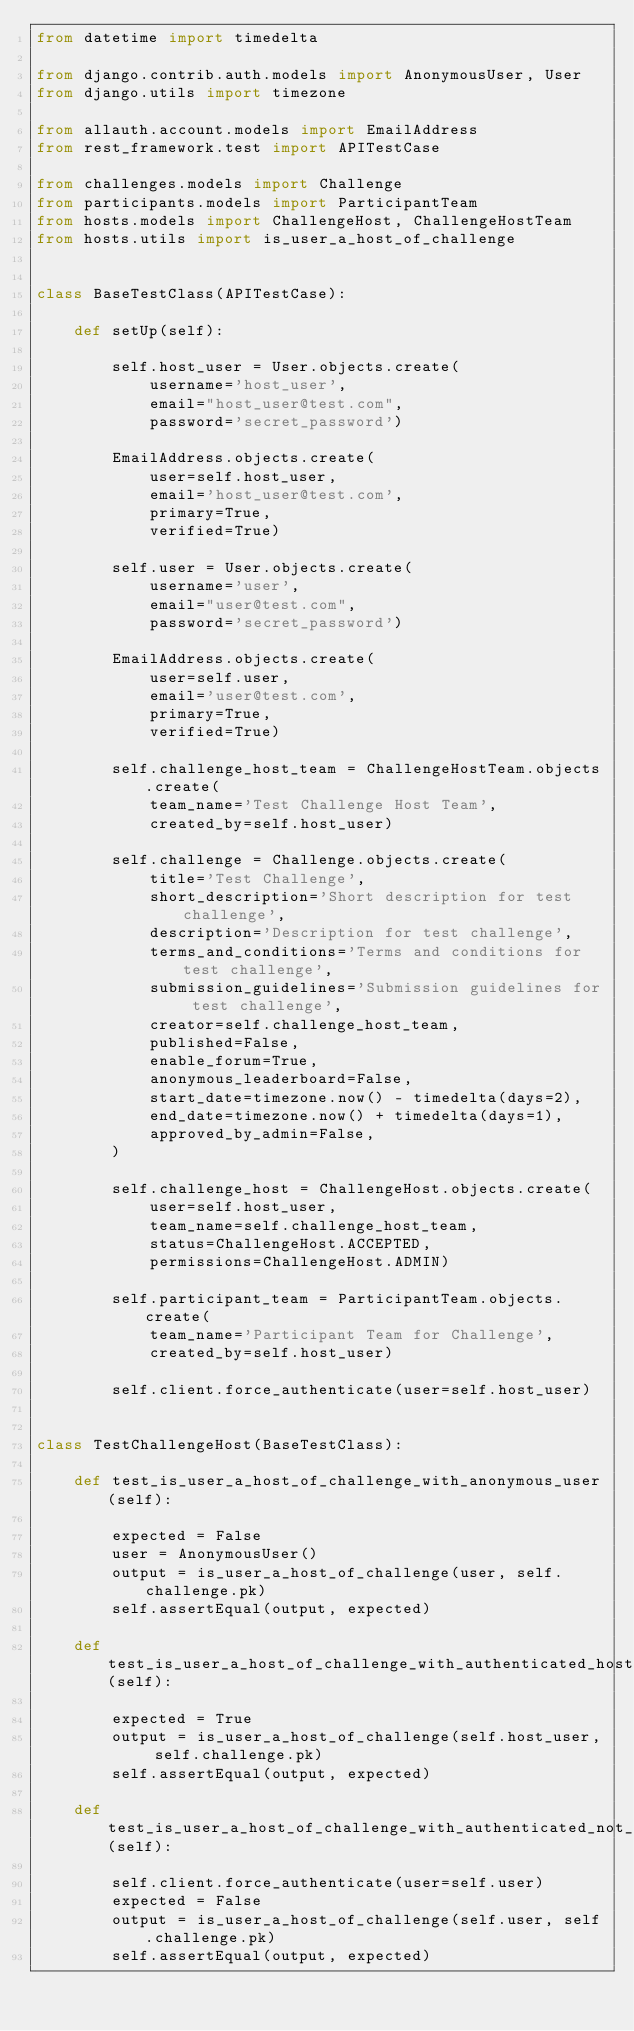<code> <loc_0><loc_0><loc_500><loc_500><_Python_>from datetime import timedelta

from django.contrib.auth.models import AnonymousUser, User
from django.utils import timezone

from allauth.account.models import EmailAddress
from rest_framework.test import APITestCase

from challenges.models import Challenge
from participants.models import ParticipantTeam
from hosts.models import ChallengeHost, ChallengeHostTeam
from hosts.utils import is_user_a_host_of_challenge


class BaseTestClass(APITestCase):

    def setUp(self):

        self.host_user = User.objects.create(
            username='host_user',
            email="host_user@test.com",
            password='secret_password')

        EmailAddress.objects.create(
            user=self.host_user,
            email='host_user@test.com',
            primary=True,
            verified=True)

        self.user = User.objects.create(
            username='user',
            email="user@test.com",
            password='secret_password')

        EmailAddress.objects.create(
            user=self.user,
            email='user@test.com',
            primary=True,
            verified=True)

        self.challenge_host_team = ChallengeHostTeam.objects.create(
            team_name='Test Challenge Host Team',
            created_by=self.host_user)

        self.challenge = Challenge.objects.create(
            title='Test Challenge',
            short_description='Short description for test challenge',
            description='Description for test challenge',
            terms_and_conditions='Terms and conditions for test challenge',
            submission_guidelines='Submission guidelines for test challenge',
            creator=self.challenge_host_team,
            published=False,
            enable_forum=True,
            anonymous_leaderboard=False,
            start_date=timezone.now() - timedelta(days=2),
            end_date=timezone.now() + timedelta(days=1),
            approved_by_admin=False,
        )

        self.challenge_host = ChallengeHost.objects.create(
            user=self.host_user,
            team_name=self.challenge_host_team,
            status=ChallengeHost.ACCEPTED,
            permissions=ChallengeHost.ADMIN)

        self.participant_team = ParticipantTeam.objects.create(
            team_name='Participant Team for Challenge',
            created_by=self.host_user)

        self.client.force_authenticate(user=self.host_user)


class TestChallengeHost(BaseTestClass):

    def test_is_user_a_host_of_challenge_with_anonymous_user(self):

        expected = False
        user = AnonymousUser()
        output = is_user_a_host_of_challenge(user, self.challenge.pk)
        self.assertEqual(output, expected)

    def test_is_user_a_host_of_challenge_with_authenticated_host_user(self):

        expected = True
        output = is_user_a_host_of_challenge(self.host_user, self.challenge.pk)
        self.assertEqual(output, expected)

    def test_is_user_a_host_of_challenge_with_authenticated_not_host_user(self):

        self.client.force_authenticate(user=self.user)
        expected = False
        output = is_user_a_host_of_challenge(self.user, self.challenge.pk)
        self.assertEqual(output, expected)
</code> 